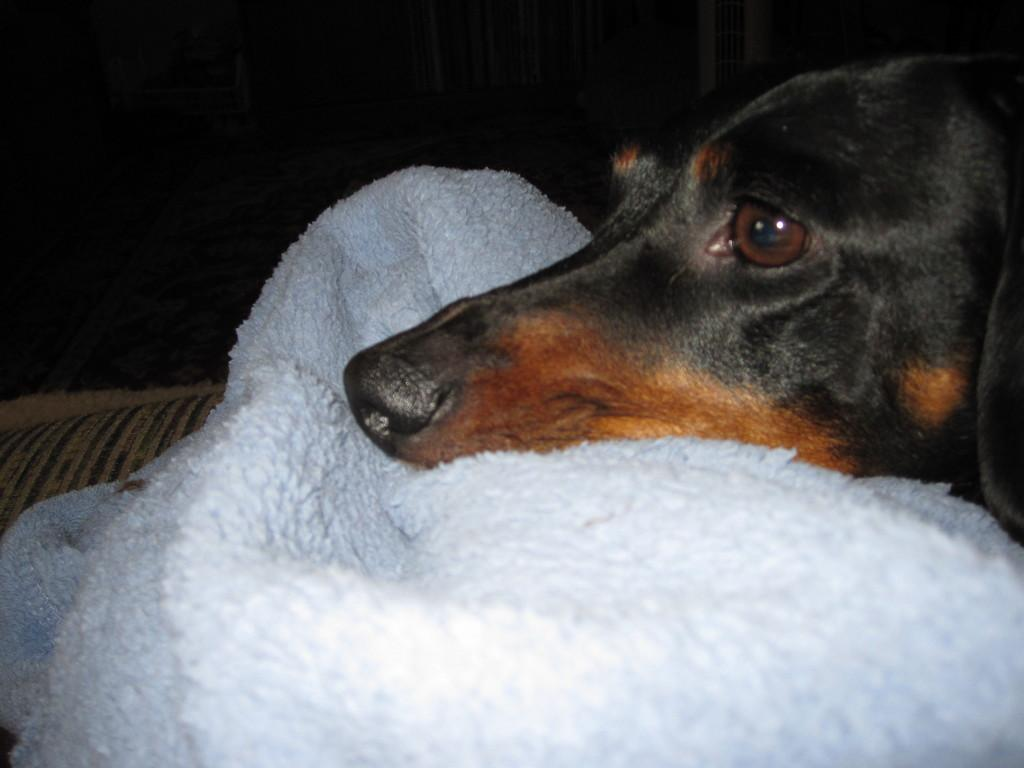What type of animal is in the image? There is a black color dog in the image. What is the dog standing on? The dog is on white color clothes. How would you describe the overall lighting or brightness of the image? The background of the image is dark. What type of beast can be seen roaming the range in the image? There is no beast or range present in the image; it features a black color dog standing on white color clothes. 